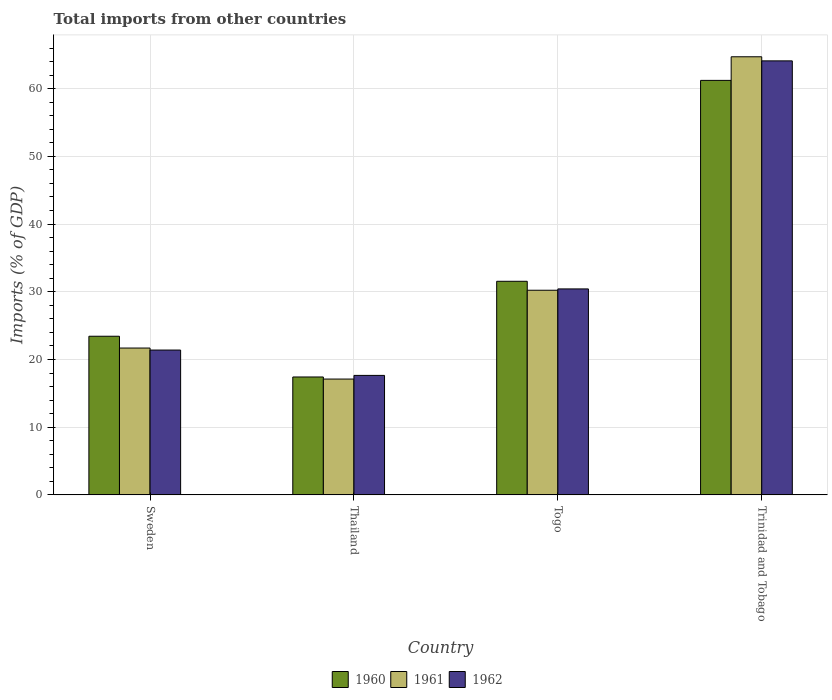Are the number of bars per tick equal to the number of legend labels?
Ensure brevity in your answer.  Yes. How many bars are there on the 1st tick from the left?
Provide a short and direct response. 3. What is the label of the 4th group of bars from the left?
Your answer should be compact. Trinidad and Tobago. In how many cases, is the number of bars for a given country not equal to the number of legend labels?
Provide a short and direct response. 0. What is the total imports in 1960 in Togo?
Offer a very short reply. 31.55. Across all countries, what is the maximum total imports in 1961?
Ensure brevity in your answer.  64.71. Across all countries, what is the minimum total imports in 1962?
Your answer should be compact. 17.65. In which country was the total imports in 1960 maximum?
Ensure brevity in your answer.  Trinidad and Tobago. In which country was the total imports in 1962 minimum?
Provide a succinct answer. Thailand. What is the total total imports in 1960 in the graph?
Provide a short and direct response. 133.62. What is the difference between the total imports in 1960 in Togo and that in Trinidad and Tobago?
Offer a very short reply. -29.67. What is the difference between the total imports in 1962 in Togo and the total imports in 1960 in Thailand?
Make the answer very short. 13.01. What is the average total imports in 1960 per country?
Your response must be concise. 33.4. What is the difference between the total imports of/in 1960 and total imports of/in 1962 in Sweden?
Keep it short and to the point. 2.04. What is the ratio of the total imports in 1962 in Sweden to that in Togo?
Your response must be concise. 0.7. What is the difference between the highest and the second highest total imports in 1961?
Offer a very short reply. 43.02. What is the difference between the highest and the lowest total imports in 1962?
Provide a succinct answer. 46.46. In how many countries, is the total imports in 1961 greater than the average total imports in 1961 taken over all countries?
Your answer should be compact. 1. What does the 2nd bar from the right in Sweden represents?
Offer a very short reply. 1961. Is it the case that in every country, the sum of the total imports in 1962 and total imports in 1960 is greater than the total imports in 1961?
Give a very brief answer. Yes. How many bars are there?
Provide a short and direct response. 12. What is the difference between two consecutive major ticks on the Y-axis?
Provide a succinct answer. 10. Are the values on the major ticks of Y-axis written in scientific E-notation?
Ensure brevity in your answer.  No. Does the graph contain grids?
Provide a short and direct response. Yes. Where does the legend appear in the graph?
Your answer should be very brief. Bottom center. How many legend labels are there?
Provide a short and direct response. 3. What is the title of the graph?
Offer a very short reply. Total imports from other countries. Does "1984" appear as one of the legend labels in the graph?
Ensure brevity in your answer.  No. What is the label or title of the X-axis?
Your response must be concise. Country. What is the label or title of the Y-axis?
Provide a short and direct response. Imports (% of GDP). What is the Imports (% of GDP) of 1960 in Sweden?
Provide a short and direct response. 23.43. What is the Imports (% of GDP) in 1961 in Sweden?
Offer a very short reply. 21.69. What is the Imports (% of GDP) of 1962 in Sweden?
Your response must be concise. 21.39. What is the Imports (% of GDP) of 1960 in Thailand?
Offer a very short reply. 17.42. What is the Imports (% of GDP) in 1961 in Thailand?
Your answer should be compact. 17.11. What is the Imports (% of GDP) of 1962 in Thailand?
Your answer should be compact. 17.65. What is the Imports (% of GDP) of 1960 in Togo?
Your response must be concise. 31.55. What is the Imports (% of GDP) of 1961 in Togo?
Your response must be concise. 30.23. What is the Imports (% of GDP) of 1962 in Togo?
Your answer should be very brief. 30.42. What is the Imports (% of GDP) of 1960 in Trinidad and Tobago?
Your response must be concise. 61.22. What is the Imports (% of GDP) in 1961 in Trinidad and Tobago?
Give a very brief answer. 64.71. What is the Imports (% of GDP) in 1962 in Trinidad and Tobago?
Offer a terse response. 64.1. Across all countries, what is the maximum Imports (% of GDP) of 1960?
Ensure brevity in your answer.  61.22. Across all countries, what is the maximum Imports (% of GDP) in 1961?
Keep it short and to the point. 64.71. Across all countries, what is the maximum Imports (% of GDP) of 1962?
Make the answer very short. 64.1. Across all countries, what is the minimum Imports (% of GDP) in 1960?
Provide a succinct answer. 17.42. Across all countries, what is the minimum Imports (% of GDP) in 1961?
Offer a terse response. 17.11. Across all countries, what is the minimum Imports (% of GDP) of 1962?
Your response must be concise. 17.65. What is the total Imports (% of GDP) of 1960 in the graph?
Your response must be concise. 133.62. What is the total Imports (% of GDP) in 1961 in the graph?
Give a very brief answer. 133.74. What is the total Imports (% of GDP) of 1962 in the graph?
Ensure brevity in your answer.  133.57. What is the difference between the Imports (% of GDP) in 1960 in Sweden and that in Thailand?
Your answer should be compact. 6.02. What is the difference between the Imports (% of GDP) in 1961 in Sweden and that in Thailand?
Your answer should be very brief. 4.58. What is the difference between the Imports (% of GDP) in 1962 in Sweden and that in Thailand?
Give a very brief answer. 3.74. What is the difference between the Imports (% of GDP) in 1960 in Sweden and that in Togo?
Your response must be concise. -8.12. What is the difference between the Imports (% of GDP) of 1961 in Sweden and that in Togo?
Make the answer very short. -8.53. What is the difference between the Imports (% of GDP) in 1962 in Sweden and that in Togo?
Ensure brevity in your answer.  -9.03. What is the difference between the Imports (% of GDP) in 1960 in Sweden and that in Trinidad and Tobago?
Make the answer very short. -37.79. What is the difference between the Imports (% of GDP) of 1961 in Sweden and that in Trinidad and Tobago?
Offer a very short reply. -43.02. What is the difference between the Imports (% of GDP) of 1962 in Sweden and that in Trinidad and Tobago?
Make the answer very short. -42.71. What is the difference between the Imports (% of GDP) in 1960 in Thailand and that in Togo?
Your answer should be compact. -14.13. What is the difference between the Imports (% of GDP) of 1961 in Thailand and that in Togo?
Keep it short and to the point. -13.12. What is the difference between the Imports (% of GDP) of 1962 in Thailand and that in Togo?
Your answer should be compact. -12.77. What is the difference between the Imports (% of GDP) in 1960 in Thailand and that in Trinidad and Tobago?
Keep it short and to the point. -43.81. What is the difference between the Imports (% of GDP) of 1961 in Thailand and that in Trinidad and Tobago?
Your answer should be compact. -47.6. What is the difference between the Imports (% of GDP) in 1962 in Thailand and that in Trinidad and Tobago?
Your answer should be very brief. -46.46. What is the difference between the Imports (% of GDP) of 1960 in Togo and that in Trinidad and Tobago?
Give a very brief answer. -29.67. What is the difference between the Imports (% of GDP) of 1961 in Togo and that in Trinidad and Tobago?
Provide a short and direct response. -34.48. What is the difference between the Imports (% of GDP) in 1962 in Togo and that in Trinidad and Tobago?
Your answer should be compact. -33.68. What is the difference between the Imports (% of GDP) in 1960 in Sweden and the Imports (% of GDP) in 1961 in Thailand?
Make the answer very short. 6.32. What is the difference between the Imports (% of GDP) of 1960 in Sweden and the Imports (% of GDP) of 1962 in Thailand?
Keep it short and to the point. 5.78. What is the difference between the Imports (% of GDP) in 1961 in Sweden and the Imports (% of GDP) in 1962 in Thailand?
Your answer should be very brief. 4.04. What is the difference between the Imports (% of GDP) of 1960 in Sweden and the Imports (% of GDP) of 1961 in Togo?
Keep it short and to the point. -6.79. What is the difference between the Imports (% of GDP) of 1960 in Sweden and the Imports (% of GDP) of 1962 in Togo?
Your response must be concise. -6.99. What is the difference between the Imports (% of GDP) in 1961 in Sweden and the Imports (% of GDP) in 1962 in Togo?
Your response must be concise. -8.73. What is the difference between the Imports (% of GDP) in 1960 in Sweden and the Imports (% of GDP) in 1961 in Trinidad and Tobago?
Offer a very short reply. -41.28. What is the difference between the Imports (% of GDP) of 1960 in Sweden and the Imports (% of GDP) of 1962 in Trinidad and Tobago?
Your response must be concise. -40.67. What is the difference between the Imports (% of GDP) of 1961 in Sweden and the Imports (% of GDP) of 1962 in Trinidad and Tobago?
Ensure brevity in your answer.  -42.41. What is the difference between the Imports (% of GDP) in 1960 in Thailand and the Imports (% of GDP) in 1961 in Togo?
Your answer should be very brief. -12.81. What is the difference between the Imports (% of GDP) of 1960 in Thailand and the Imports (% of GDP) of 1962 in Togo?
Offer a terse response. -13.01. What is the difference between the Imports (% of GDP) in 1961 in Thailand and the Imports (% of GDP) in 1962 in Togo?
Offer a very short reply. -13.31. What is the difference between the Imports (% of GDP) of 1960 in Thailand and the Imports (% of GDP) of 1961 in Trinidad and Tobago?
Offer a very short reply. -47.29. What is the difference between the Imports (% of GDP) in 1960 in Thailand and the Imports (% of GDP) in 1962 in Trinidad and Tobago?
Ensure brevity in your answer.  -46.69. What is the difference between the Imports (% of GDP) of 1961 in Thailand and the Imports (% of GDP) of 1962 in Trinidad and Tobago?
Your answer should be very brief. -46.99. What is the difference between the Imports (% of GDP) in 1960 in Togo and the Imports (% of GDP) in 1961 in Trinidad and Tobago?
Provide a short and direct response. -33.16. What is the difference between the Imports (% of GDP) of 1960 in Togo and the Imports (% of GDP) of 1962 in Trinidad and Tobago?
Provide a short and direct response. -32.56. What is the difference between the Imports (% of GDP) in 1961 in Togo and the Imports (% of GDP) in 1962 in Trinidad and Tobago?
Your answer should be very brief. -33.88. What is the average Imports (% of GDP) in 1960 per country?
Provide a short and direct response. 33.4. What is the average Imports (% of GDP) of 1961 per country?
Offer a terse response. 33.43. What is the average Imports (% of GDP) of 1962 per country?
Your response must be concise. 33.39. What is the difference between the Imports (% of GDP) in 1960 and Imports (% of GDP) in 1961 in Sweden?
Your answer should be compact. 1.74. What is the difference between the Imports (% of GDP) of 1960 and Imports (% of GDP) of 1962 in Sweden?
Your answer should be compact. 2.04. What is the difference between the Imports (% of GDP) in 1961 and Imports (% of GDP) in 1962 in Sweden?
Keep it short and to the point. 0.3. What is the difference between the Imports (% of GDP) of 1960 and Imports (% of GDP) of 1961 in Thailand?
Give a very brief answer. 0.31. What is the difference between the Imports (% of GDP) of 1960 and Imports (% of GDP) of 1962 in Thailand?
Your response must be concise. -0.23. What is the difference between the Imports (% of GDP) in 1961 and Imports (% of GDP) in 1962 in Thailand?
Provide a short and direct response. -0.54. What is the difference between the Imports (% of GDP) of 1960 and Imports (% of GDP) of 1961 in Togo?
Provide a succinct answer. 1.32. What is the difference between the Imports (% of GDP) of 1960 and Imports (% of GDP) of 1962 in Togo?
Make the answer very short. 1.13. What is the difference between the Imports (% of GDP) in 1961 and Imports (% of GDP) in 1962 in Togo?
Your response must be concise. -0.2. What is the difference between the Imports (% of GDP) of 1960 and Imports (% of GDP) of 1961 in Trinidad and Tobago?
Your answer should be compact. -3.49. What is the difference between the Imports (% of GDP) of 1960 and Imports (% of GDP) of 1962 in Trinidad and Tobago?
Your response must be concise. -2.88. What is the difference between the Imports (% of GDP) of 1961 and Imports (% of GDP) of 1962 in Trinidad and Tobago?
Your answer should be compact. 0.6. What is the ratio of the Imports (% of GDP) of 1960 in Sweden to that in Thailand?
Give a very brief answer. 1.35. What is the ratio of the Imports (% of GDP) in 1961 in Sweden to that in Thailand?
Ensure brevity in your answer.  1.27. What is the ratio of the Imports (% of GDP) of 1962 in Sweden to that in Thailand?
Make the answer very short. 1.21. What is the ratio of the Imports (% of GDP) in 1960 in Sweden to that in Togo?
Keep it short and to the point. 0.74. What is the ratio of the Imports (% of GDP) of 1961 in Sweden to that in Togo?
Keep it short and to the point. 0.72. What is the ratio of the Imports (% of GDP) of 1962 in Sweden to that in Togo?
Give a very brief answer. 0.7. What is the ratio of the Imports (% of GDP) in 1960 in Sweden to that in Trinidad and Tobago?
Give a very brief answer. 0.38. What is the ratio of the Imports (% of GDP) in 1961 in Sweden to that in Trinidad and Tobago?
Keep it short and to the point. 0.34. What is the ratio of the Imports (% of GDP) of 1962 in Sweden to that in Trinidad and Tobago?
Make the answer very short. 0.33. What is the ratio of the Imports (% of GDP) of 1960 in Thailand to that in Togo?
Make the answer very short. 0.55. What is the ratio of the Imports (% of GDP) in 1961 in Thailand to that in Togo?
Offer a terse response. 0.57. What is the ratio of the Imports (% of GDP) of 1962 in Thailand to that in Togo?
Your answer should be very brief. 0.58. What is the ratio of the Imports (% of GDP) of 1960 in Thailand to that in Trinidad and Tobago?
Make the answer very short. 0.28. What is the ratio of the Imports (% of GDP) in 1961 in Thailand to that in Trinidad and Tobago?
Offer a very short reply. 0.26. What is the ratio of the Imports (% of GDP) of 1962 in Thailand to that in Trinidad and Tobago?
Keep it short and to the point. 0.28. What is the ratio of the Imports (% of GDP) of 1960 in Togo to that in Trinidad and Tobago?
Your response must be concise. 0.52. What is the ratio of the Imports (% of GDP) in 1961 in Togo to that in Trinidad and Tobago?
Provide a succinct answer. 0.47. What is the ratio of the Imports (% of GDP) in 1962 in Togo to that in Trinidad and Tobago?
Offer a terse response. 0.47. What is the difference between the highest and the second highest Imports (% of GDP) of 1960?
Keep it short and to the point. 29.67. What is the difference between the highest and the second highest Imports (% of GDP) in 1961?
Provide a succinct answer. 34.48. What is the difference between the highest and the second highest Imports (% of GDP) of 1962?
Your response must be concise. 33.68. What is the difference between the highest and the lowest Imports (% of GDP) of 1960?
Give a very brief answer. 43.81. What is the difference between the highest and the lowest Imports (% of GDP) in 1961?
Your response must be concise. 47.6. What is the difference between the highest and the lowest Imports (% of GDP) in 1962?
Your answer should be very brief. 46.46. 